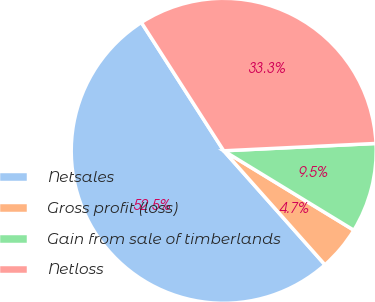Convert chart. <chart><loc_0><loc_0><loc_500><loc_500><pie_chart><fcel>Netsales<fcel>Gross profit (loss)<fcel>Gain from sale of timberlands<fcel>Netloss<nl><fcel>52.48%<fcel>4.72%<fcel>9.49%<fcel>33.31%<nl></chart> 